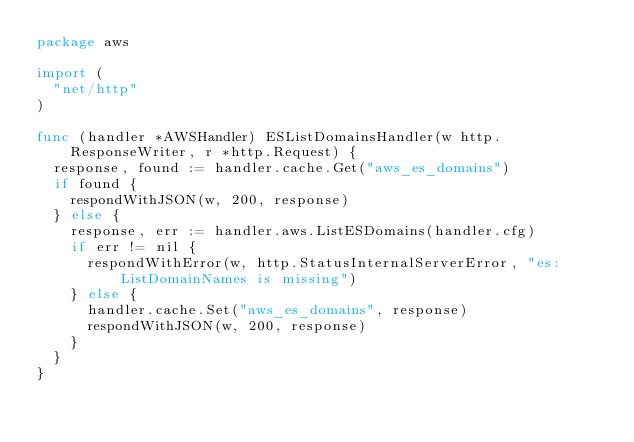<code> <loc_0><loc_0><loc_500><loc_500><_Go_>package aws

import (
	"net/http"
)

func (handler *AWSHandler) ESListDomainsHandler(w http.ResponseWriter, r *http.Request) {
	response, found := handler.cache.Get("aws_es_domains")
	if found {
		respondWithJSON(w, 200, response)
	} else {
		response, err := handler.aws.ListESDomains(handler.cfg)
		if err != nil {
			respondWithError(w, http.StatusInternalServerError, "es:ListDomainNames is missing")
		} else {
			handler.cache.Set("aws_es_domains", response)
			respondWithJSON(w, 200, response)
		}
	}
}
</code> 